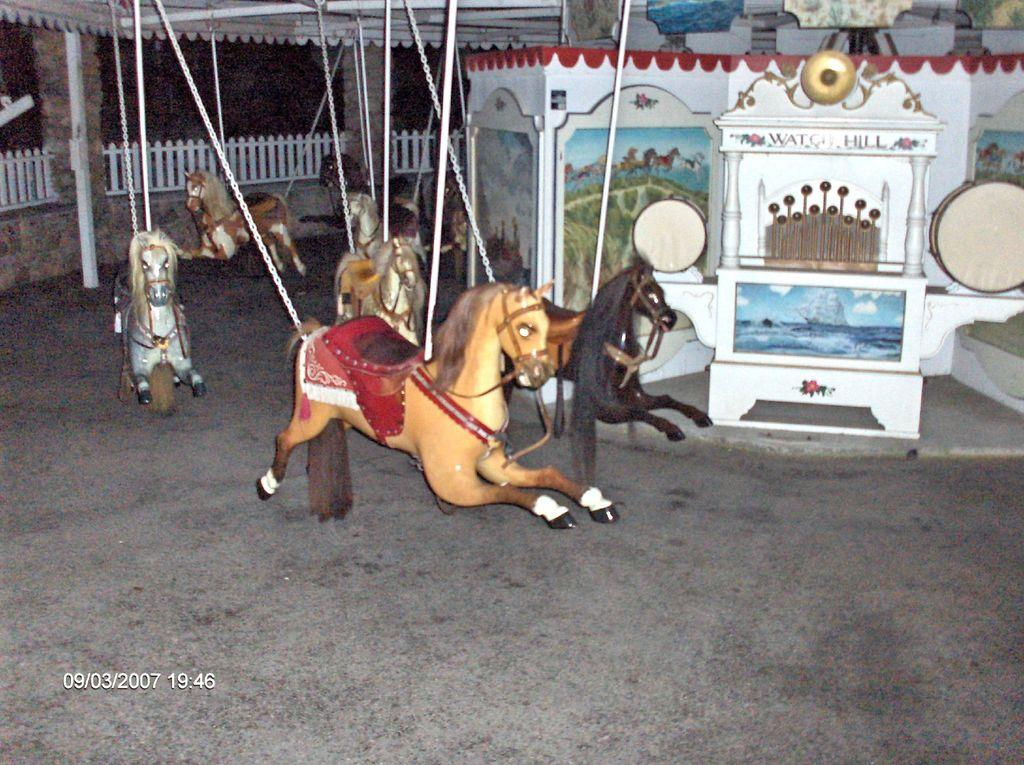What type of ride is featured in the image? There is a swing ride in the image. What can be seen in the background of the image? There is a fence in the background of the image. Is there any additional information about the image itself? Yes, there is a watermark on the image. What type of leather is used to make the seats on the swing ride? There is no information about the material used for the seats on the swing ride in the image. 